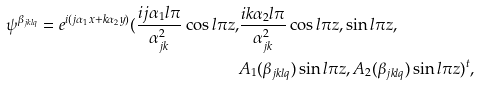<formula> <loc_0><loc_0><loc_500><loc_500>\psi ^ { \beta _ { j k l q } } = e ^ { i ( j \alpha _ { 1 } x + k \alpha _ { 2 } y ) } ( \frac { i j \alpha _ { 1 } l \pi } { \alpha _ { j k } ^ { 2 } } \cos l \pi z , & \frac { i k \alpha _ { 2 } l \pi } { \alpha _ { j k } ^ { 2 } } \cos l \pi z , \sin l \pi z , \\ & A _ { 1 } ( \beta _ { j k l q } ) \sin l \pi z , A _ { 2 } ( \beta _ { j k l q } ) \sin l \pi z ) ^ { t } ,</formula> 